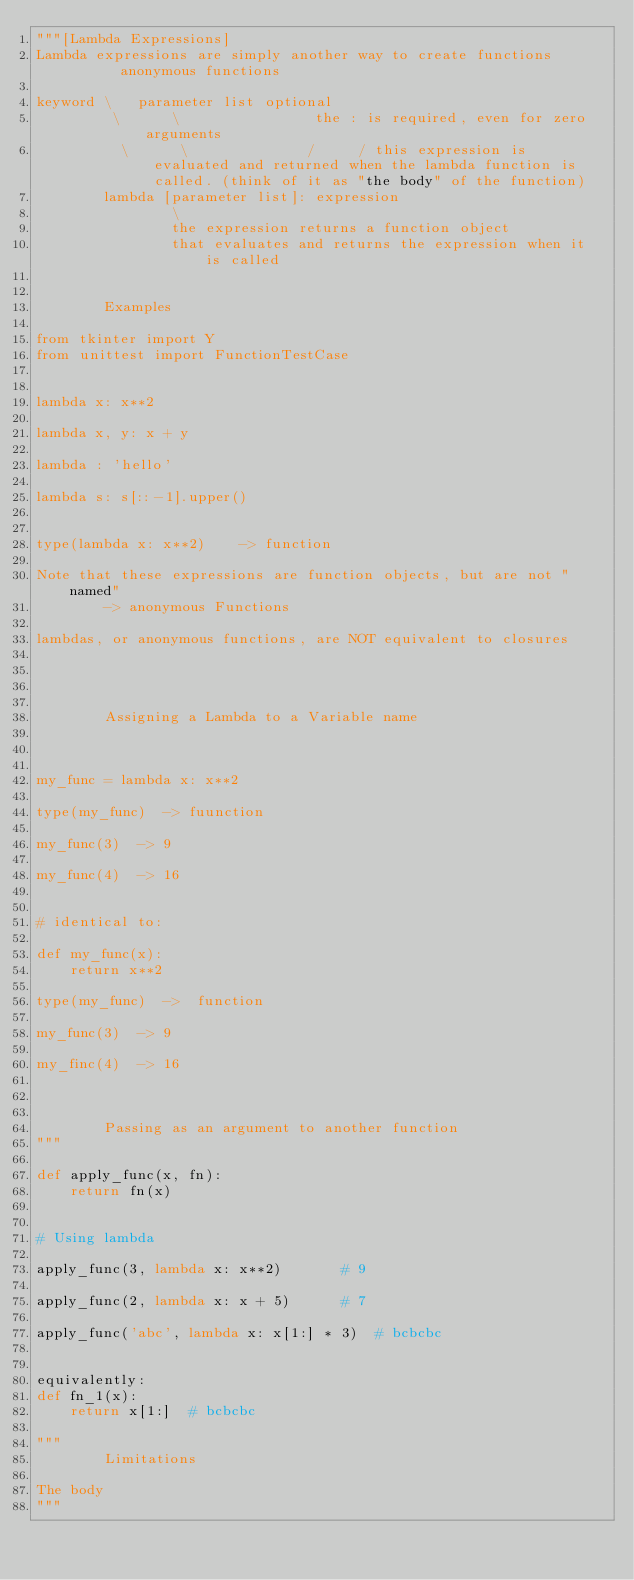<code> <loc_0><loc_0><loc_500><loc_500><_Python_>"""[Lambda Expressions]
Lambda expressions are simply another way to create functions       anonymous functions

keyword \   parameter list optional
         \      \                the : is required, even for zero arguments
          \      \              /     / this expression is evaluated and returned when the lambda function is called. (think of it as "the body" of the function)
        lambda [parameter list]: expression
                \
                the expression returns a function object
                that evaluates and returns the expression when it is called


        Examples

from tkinter import Y
from unittest import FunctionTestCase


lambda x: x**2

lambda x, y: x + y

lambda : 'hello'

lambda s: s[::-1].upper()


type(lambda x: x**2)    -> function

Note that these expressions are function objects, but are not "named"
        -> anonymous Functions

lambdas, or anonymous functions, are NOT equivalent to closures




        Assigning a Lambda to a Variable name



my_func = lambda x: x**2

type(my_func)  -> fuunction

my_func(3)  -> 9

my_func(4)  -> 16


# identical to:

def my_func(x):
	return x**2

type(my_func)  ->  function

my_func(3)  -> 9

my_finc(4)  -> 16



        Passing as an argument to another function
"""

def apply_func(x, fn):
    return fn(x)


# Using lambda

apply_func(3, lambda x: x**2)		# 9

apply_func(2, lambda x: x + 5)		# 7

apply_func('abc', lambda x: x[1:] * 3)	# bcbcbc


equivalently:
def fn_1(x):
    return x[1:]  # bcbcbc

"""
		Limitations

The body
"""

</code> 